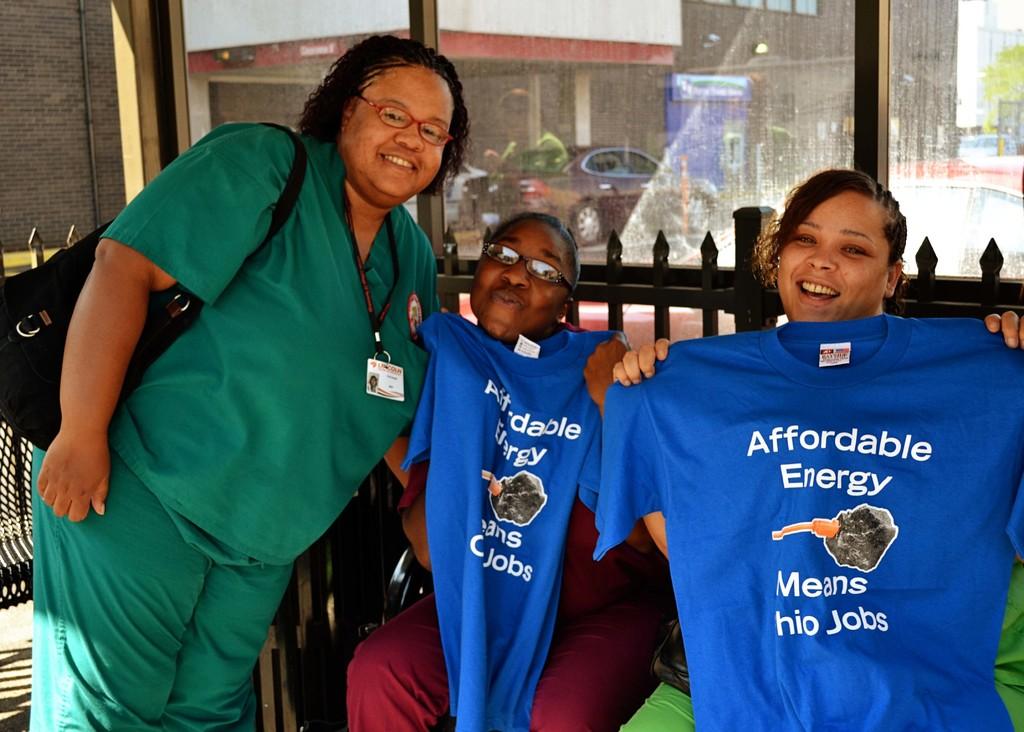What the the teachers advertising?
Ensure brevity in your answer.  Affordable energy. Affordable energy means what?
Give a very brief answer. Ohio jobs. 